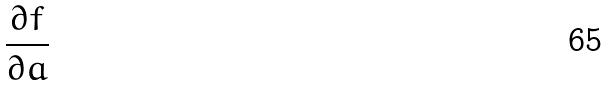Convert formula to latex. <formula><loc_0><loc_0><loc_500><loc_500>\frac { \partial f } { \partial a }</formula> 